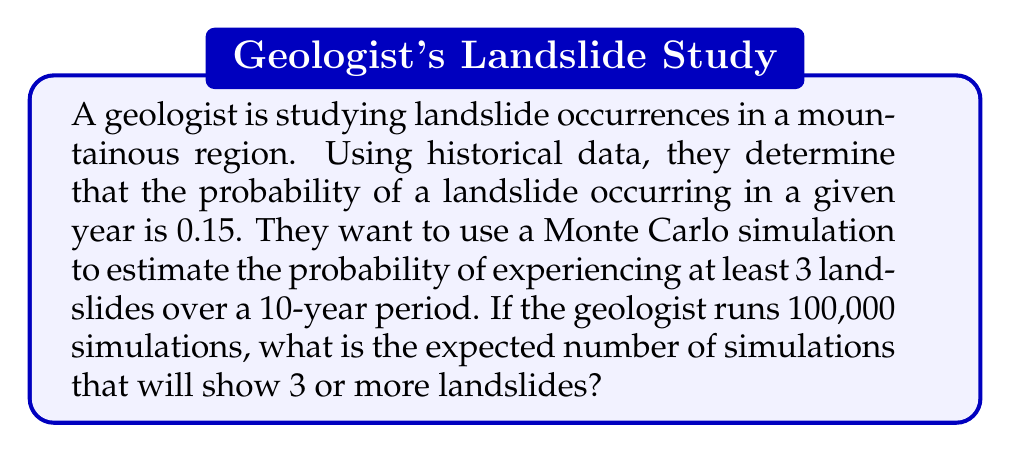What is the answer to this math problem? Let's approach this step-by-step:

1) First, we need to understand what the Monte Carlo simulation is doing. For each simulation, it's essentially performing 10 Bernoulli trials (one for each year), where the probability of success (a landslide occurring) is 0.15.

2) The number of landslides in a 10-year period follows a Binomial distribution with parameters $n=10$ and $p=0.15$.

3) We want to find $P(X \geq 3)$ where $X$ is the number of landslides in 10 years.

4) Using the binomial probability formula:

   $$P(X \geq 3) = 1 - P(X < 3) = 1 - [P(X=0) + P(X=1) + P(X=2)]$$

5) Calculate each probability:

   $$P(X=k) = \binom{10}{k} (0.15)^k (0.85)^{10-k}$$

   $$P(X=0) = \binom{10}{0} (0.15)^0 (0.85)^{10} = 0.1969$$
   $$P(X=1) = \binom{10}{1} (0.15)^1 (0.85)^9 = 0.3474$$
   $$P(X=2) = \binom{10}{2} (0.15)^2 (0.85)^8 = 0.2759$$

6) Sum these probabilities:

   $$P(X < 3) = 0.1969 + 0.3474 + 0.2759 = 0.8202$$

7) Therefore:

   $$P(X \geq 3) = 1 - 0.8202 = 0.1798$$

8) In 100,000 simulations, we expect this proportion of simulations to show 3 or more landslides:

   $$100,000 \times 0.1798 = 17,980$$
Answer: 17,980 simulations 